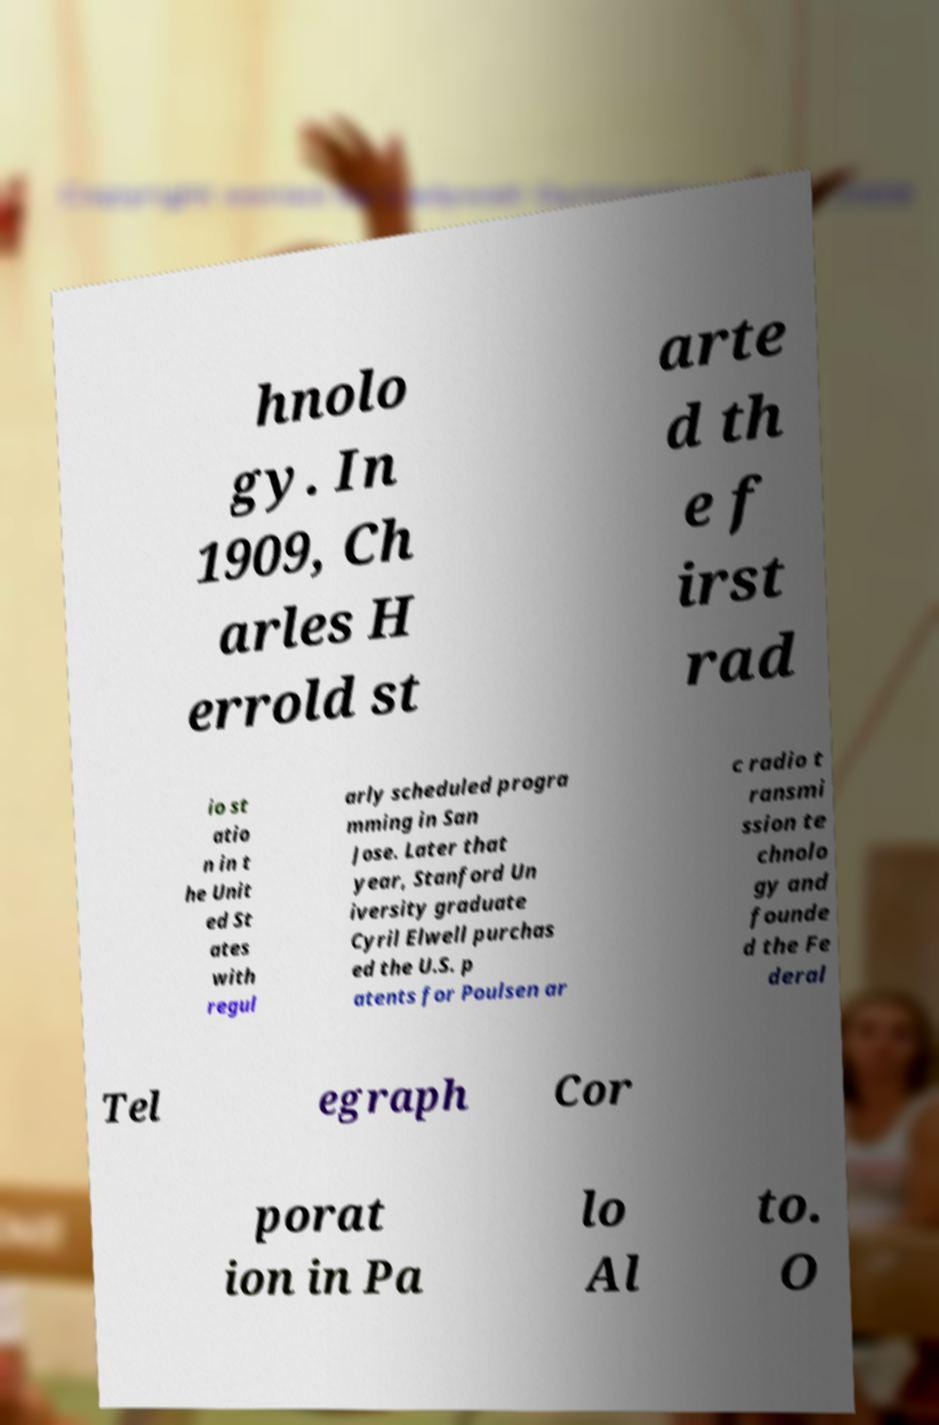Please read and relay the text visible in this image. What does it say? hnolo gy. In 1909, Ch arles H errold st arte d th e f irst rad io st atio n in t he Unit ed St ates with regul arly scheduled progra mming in San Jose. Later that year, Stanford Un iversity graduate Cyril Elwell purchas ed the U.S. p atents for Poulsen ar c radio t ransmi ssion te chnolo gy and founde d the Fe deral Tel egraph Cor porat ion in Pa lo Al to. O 